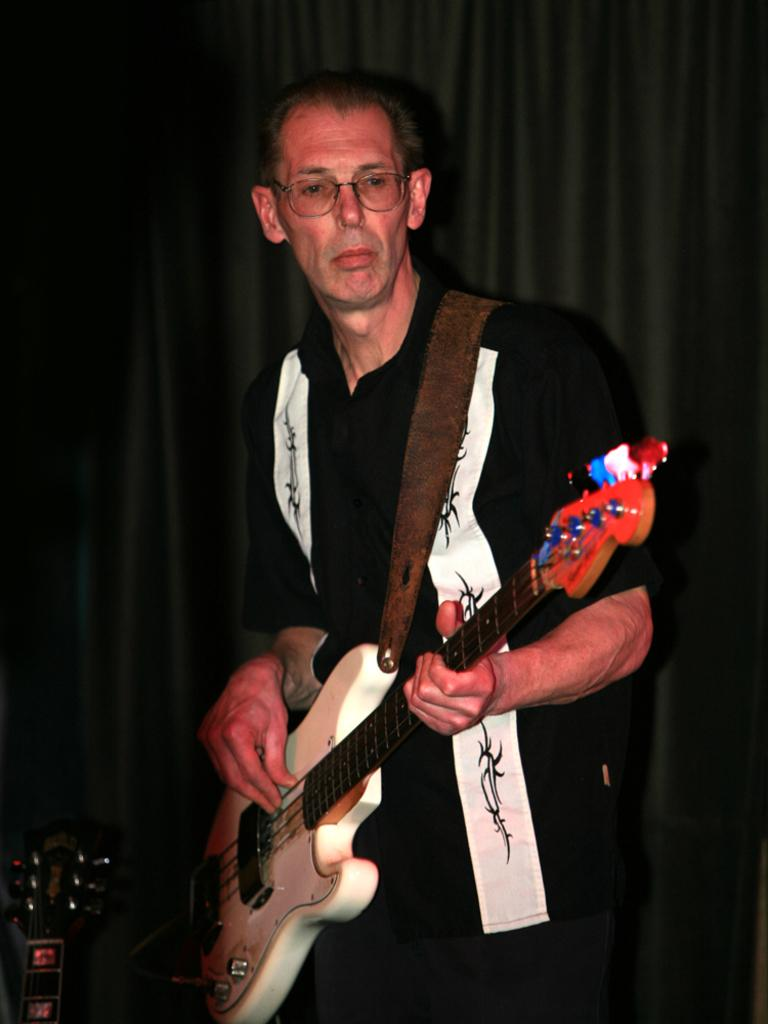What is the main subject of the image? There is a person in the image. What is the person doing in the image? The person is standing and holding a guitar in his hand. What can be seen in the background of the image? There is a black curtain in the background of the image. How many beads are hanging from the guitar in the image? There are no beads hanging from the guitar in the image. What type of building can be seen in the background of the image? There is no building visible in the background of the image; it features a black curtain. 